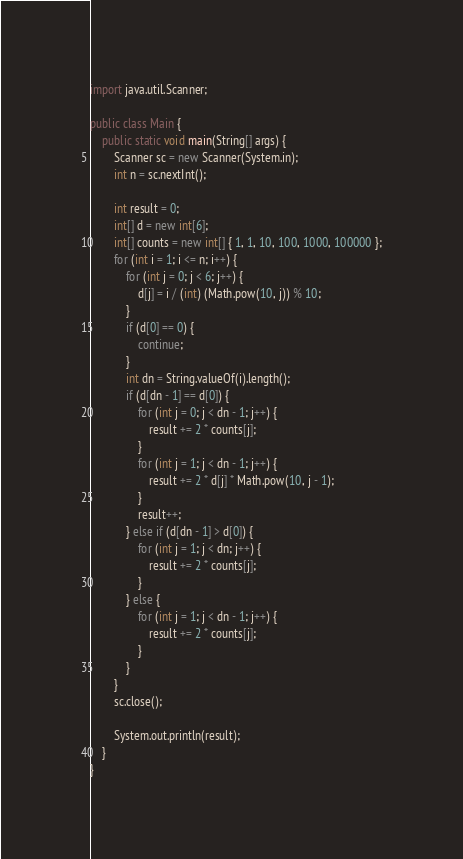<code> <loc_0><loc_0><loc_500><loc_500><_Java_>import java.util.Scanner;

public class Main {
	public static void main(String[] args) {
		Scanner sc = new Scanner(System.in);
		int n = sc.nextInt();

		int result = 0;
		int[] d = new int[6];
		int[] counts = new int[] { 1, 1, 10, 100, 1000, 100000 };
		for (int i = 1; i <= n; i++) {
			for (int j = 0; j < 6; j++) {
				d[j] = i / (int) (Math.pow(10, j)) % 10;
			}
			if (d[0] == 0) {
				continue;
			}
			int dn = String.valueOf(i).length();
			if (d[dn - 1] == d[0]) {
				for (int j = 0; j < dn - 1; j++) {
					result += 2 * counts[j];
				}
				for (int j = 1; j < dn - 1; j++) {
					result += 2 * d[j] * Math.pow(10, j - 1);
				}
				result++;
			} else if (d[dn - 1] > d[0]) {
				for (int j = 1; j < dn; j++) {
					result += 2 * counts[j];
				}
			} else {
				for (int j = 1; j < dn - 1; j++) {
					result += 2 * counts[j];
				}
			}
		}
		sc.close();

		System.out.println(result);
	}
}
</code> 